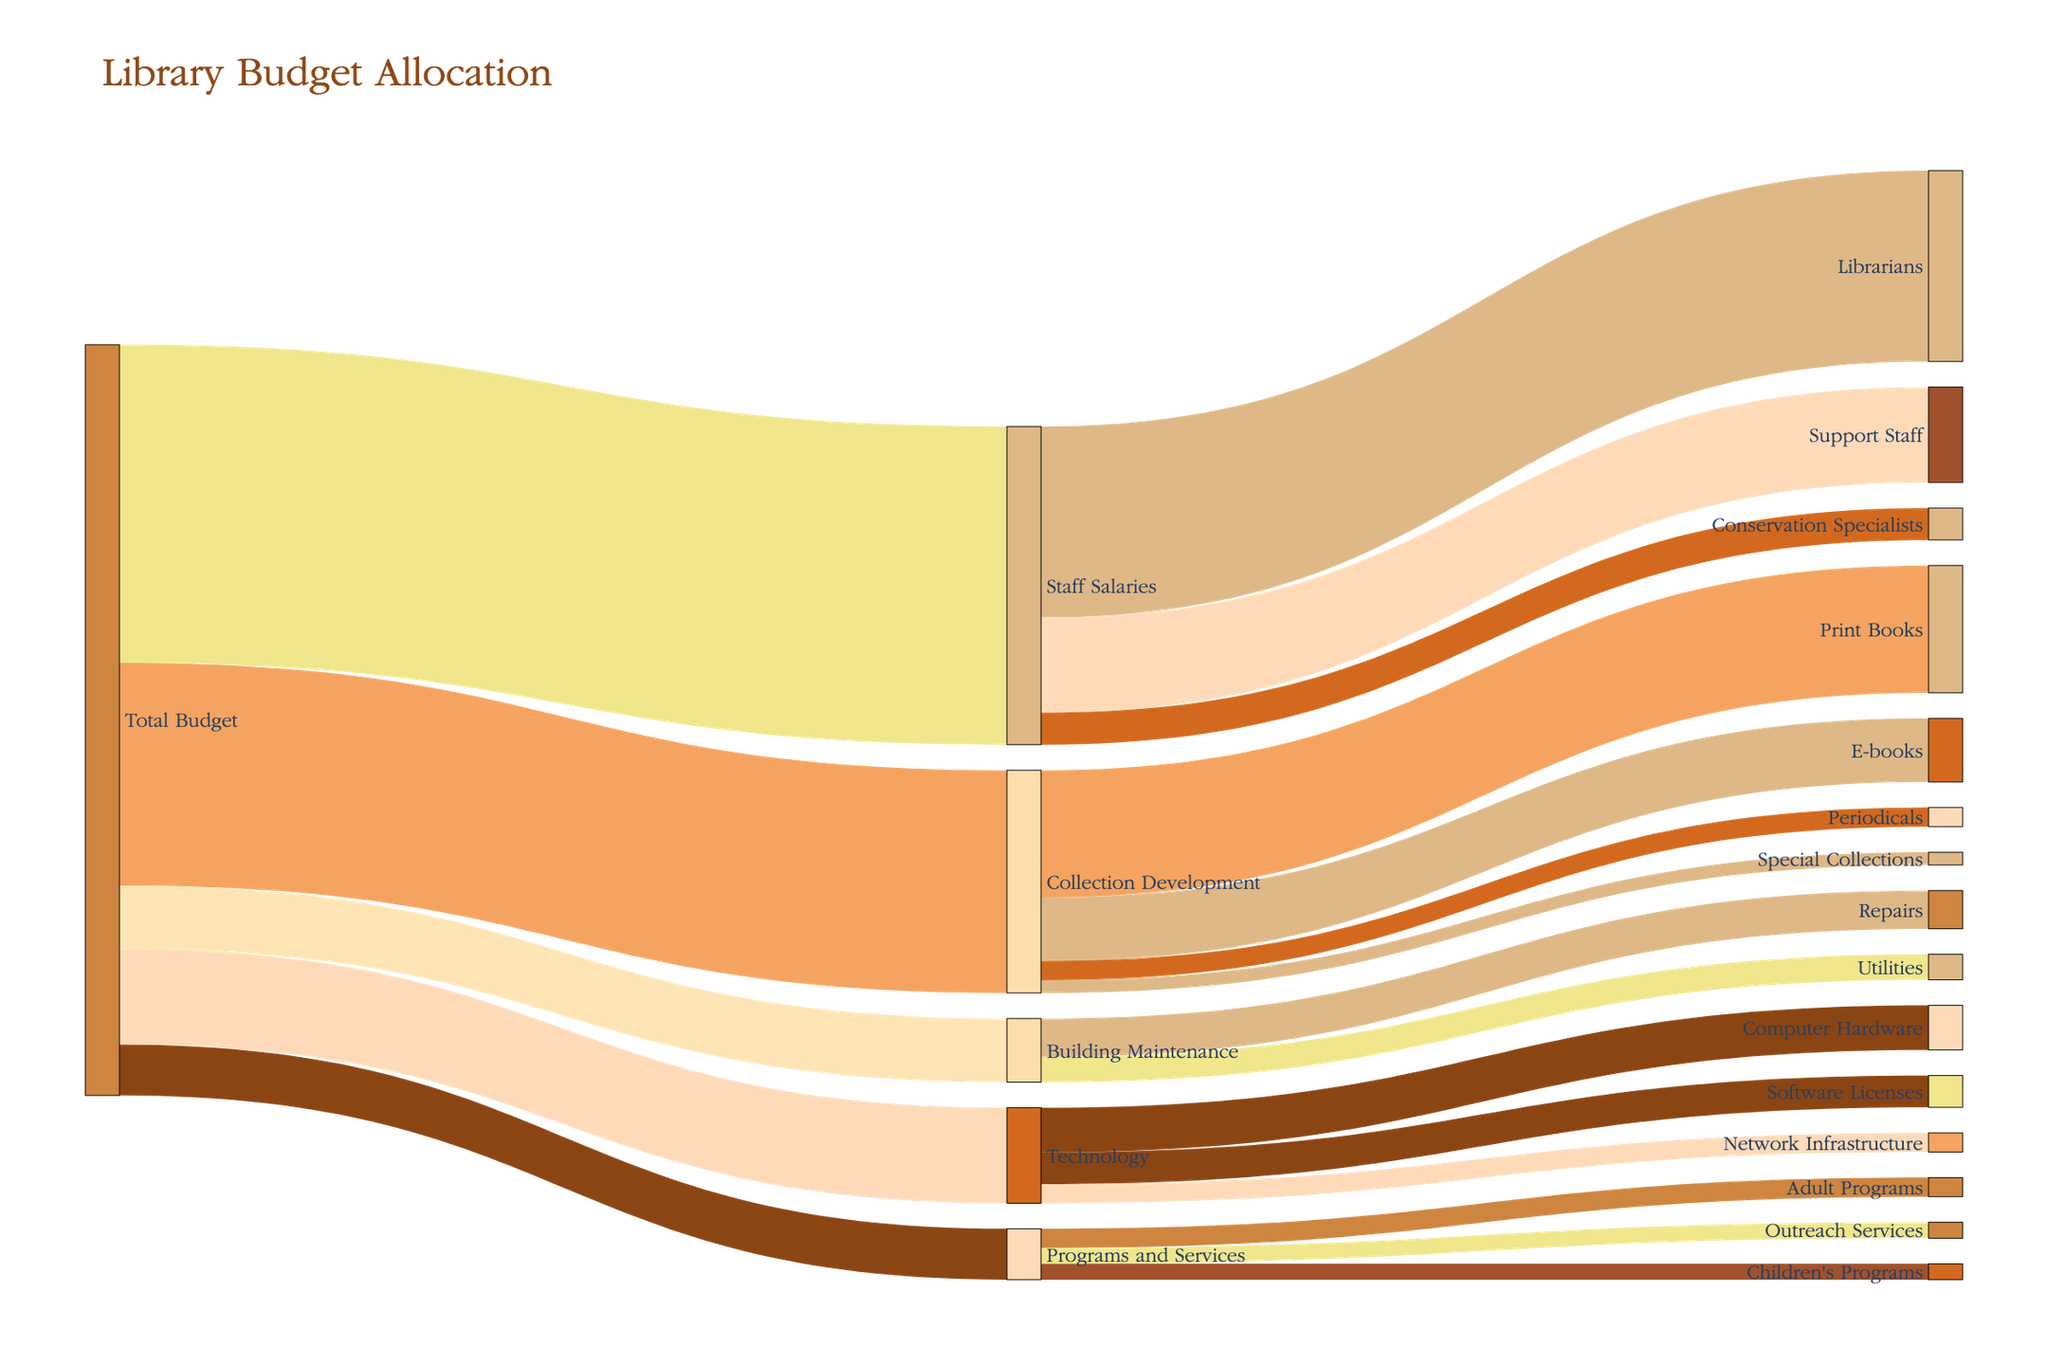What's the title of the figure? The title is typically displayed prominently at the top of the figure. In this Sankey Diagram, the title is "Library Budget Allocation," indicating the overall theme or subject matter of the figure.
Answer: "Library Budget Allocation" How much of the total budget is allocated to Collection Development? To determine the budget allocated to Collection Development, look for the flow or link originating from the Total Budget node and leading to the Collection Development node. The value associated with this flow is 350,000.
Answer: 350,000 Which department receives the highest budget allocation? Compare the values of the flows emanating from the Total Budget node to various departments. The largest flow value indicates the highest allocation, which is Staff Salaries with a value of 500,000.
Answer: Staff Salaries How much is allocated to Print Books under Collection Development? Trace the flow that begins at the Collection Development node and ends at the Print Books node. The value of this specific flow is 200,000.
Answer: 200,000 What is the combined budget for Adult Programs and Children's Programs? Identify the flows leading to Adult Programs and Children's Programs from Programs and Services. The values are 30,000 and 25,000, respectively. Summing these values gives 55,000.
Answer: 55,000 Which has a higher budget: Technology or Building Maintenance? Examine the values of the flows going to Technology and Building Maintenance from the Total Budget node. Technology receives 150,000, while Building Maintenance receives 100,000. Therefore, Technology has a higher budget.
Answer: Technology How much is allocated to Network Infrastructure under Technology? Look for the flow originating from the Technology node and terminating at the Network Infrastructure node. The value of this flow is 30,000.
Answer: 30,000 What is the total budget for Programs and Services allocation compared to Special Collections? Find the values of the flows towards Programs and Services and Special Collections. Programs and Services receives 80,000, while Special Collections receives 20,000. Programs and Services has a higher allocation.
Answer: Programs and Services Which category under Collection Development receives the least funding? Compare the values of the flows from Collection Development to each sub-category. Special Collections receives the least funding with a value of 20,000.
Answer: Special Collections What is the total budget allocated to Salaries within the Staff Salaries department? Add the values of flows to Librarians, Support Staff, and Conservation Specialists under Staff Salaries. The values are 300,000, 150,000, and 50,000, respectively, totaling 500,000.
Answer: 500,000 